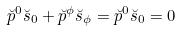Convert formula to latex. <formula><loc_0><loc_0><loc_500><loc_500>\breve { p } ^ { 0 } \breve { s } _ { 0 } + \breve { p } ^ { \phi } \breve { s } _ { \phi } = \breve { p } ^ { 0 } \breve { s } _ { 0 } = 0</formula> 